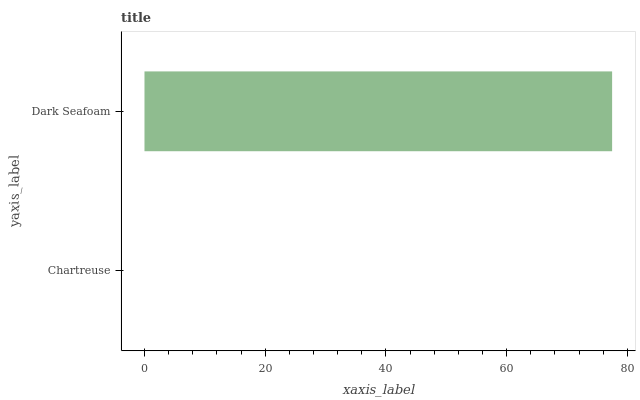Is Chartreuse the minimum?
Answer yes or no. Yes. Is Dark Seafoam the maximum?
Answer yes or no. Yes. Is Dark Seafoam the minimum?
Answer yes or no. No. Is Dark Seafoam greater than Chartreuse?
Answer yes or no. Yes. Is Chartreuse less than Dark Seafoam?
Answer yes or no. Yes. Is Chartreuse greater than Dark Seafoam?
Answer yes or no. No. Is Dark Seafoam less than Chartreuse?
Answer yes or no. No. Is Dark Seafoam the high median?
Answer yes or no. Yes. Is Chartreuse the low median?
Answer yes or no. Yes. Is Chartreuse the high median?
Answer yes or no. No. Is Dark Seafoam the low median?
Answer yes or no. No. 